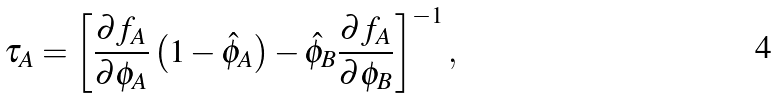<formula> <loc_0><loc_0><loc_500><loc_500>\tau _ { A } = \left [ \frac { \partial f _ { A } } { \partial { \phi } _ { A } } \left ( 1 - \hat { \phi } _ { A } \right ) - \hat { \phi } _ { B } \frac { \partial f _ { A } } { \partial { \phi } _ { B } } \right ] ^ { - 1 } ,</formula> 